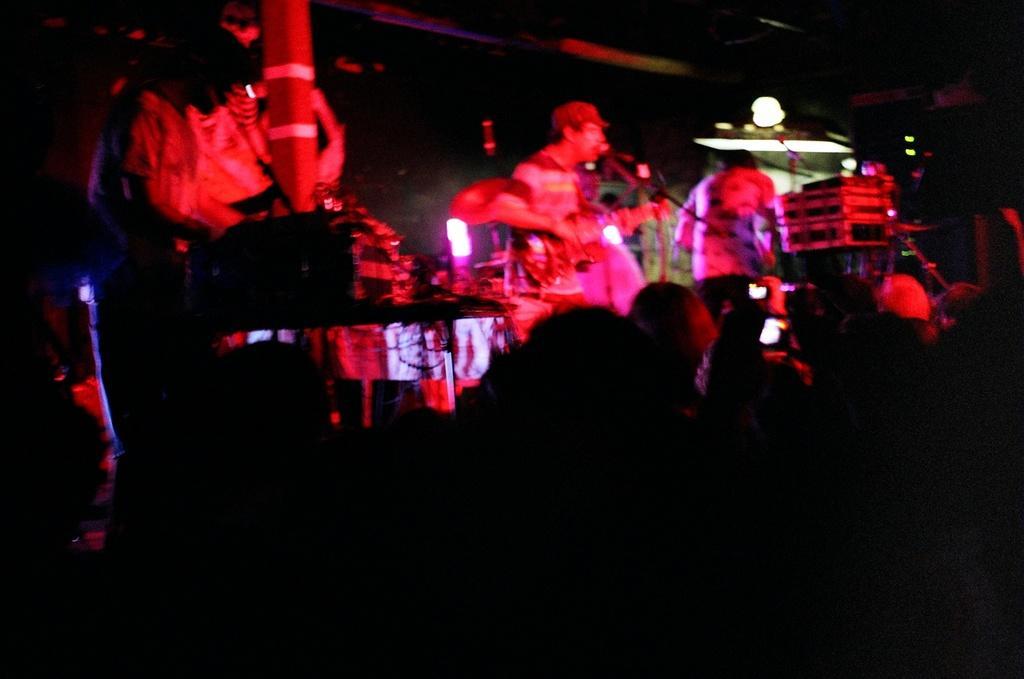In one or two sentences, can you explain what this image depicts? The picture is taken in a live concert. At the bottom it is dark and few people are standing. In the center of the picture there are people on the stage. In the center there is a person playing guitar and singing into a microphone. On the right there is a person playing guitar and there are mice and music control systems. On the left there is a person controlling music control systems. At the top it is dark. 